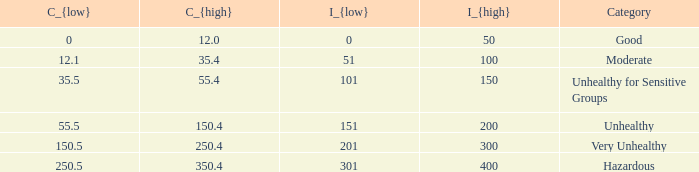5? 350.4. 